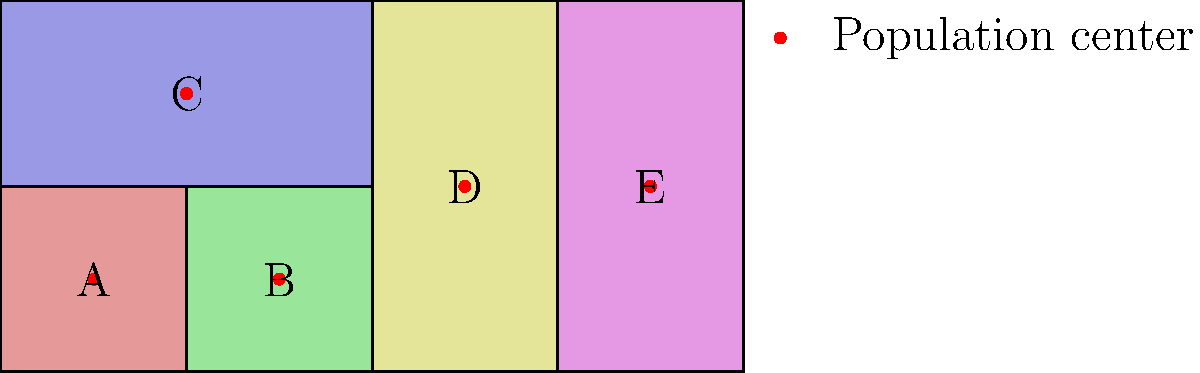Analyze the map of gerrymandered districts shown above. Which district appears to be the most egregiously gerrymandered, potentially diluting the voting power of a specific population center? To determine the most egregiously gerrymandered district, we need to consider several factors:

1. Shape irregularity: Highly irregular shapes are often indicators of gerrymandering.
2. Population distribution: How population centers are divided or grouped.
3. Compactness: Districts should ideally be compact and contiguous.

Let's analyze each district:

A and B: Regular shapes, each containing one population center.
C: Larger but still relatively regular, containing one population center.
D: Elongated shape, but still somewhat compact with one population center.
E: Highly irregular shape, stretching across the entire vertical axis of the map.

District E stands out as the most problematic for several reasons:
1. It has the most irregular shape, stretching from top to bottom of the map.
2. It divides what could be a more compact grouping of population centers.
3. Its shape suggests it may have been drawn to include or exclude specific populations.

This type of district shape is often used to dilute the voting power of certain groups by spreading them across multiple districts or concentrating them into one district. In this case, District E could be diluting the voting power of the population center within it by combining it with potentially different demographic areas to the north and south.
Answer: District E 